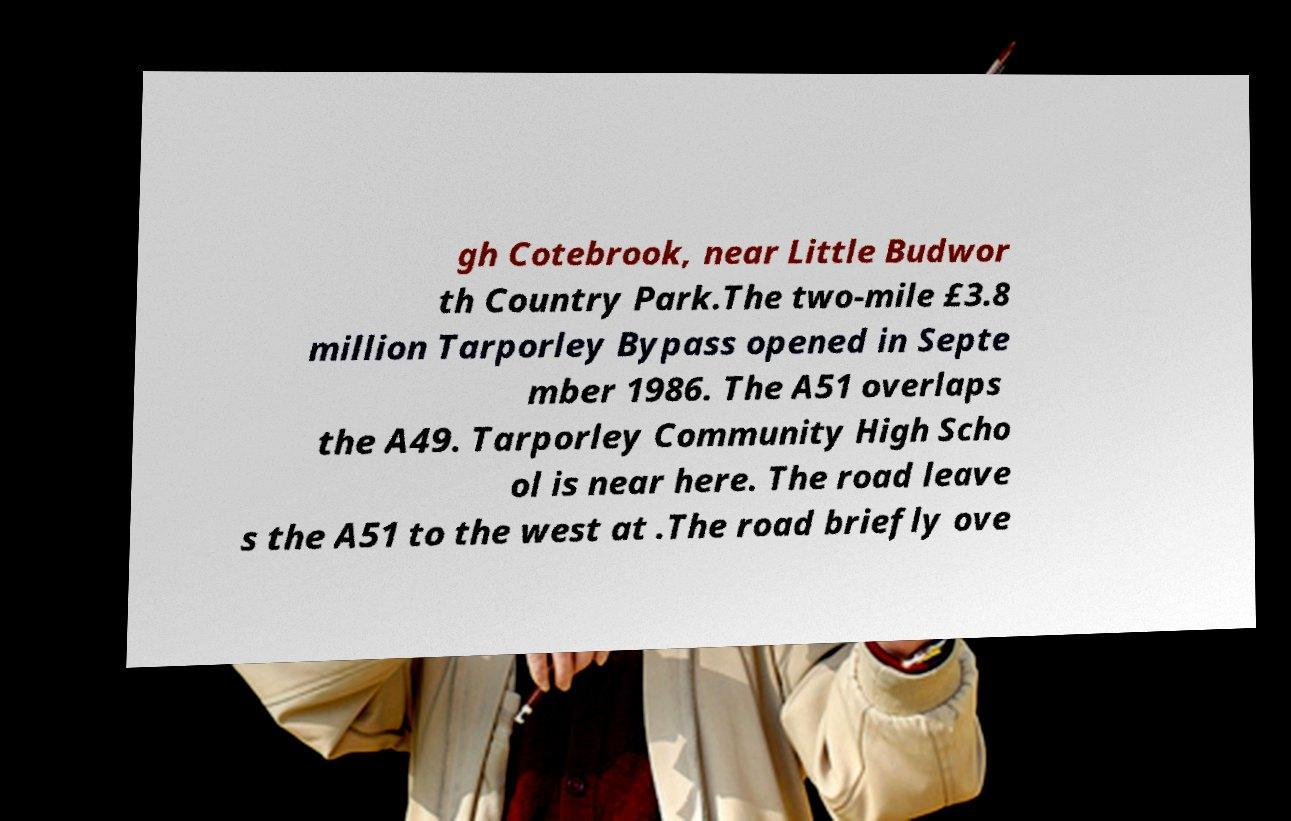For documentation purposes, I need the text within this image transcribed. Could you provide that? gh Cotebrook, near Little Budwor th Country Park.The two-mile £3.8 million Tarporley Bypass opened in Septe mber 1986. The A51 overlaps the A49. Tarporley Community High Scho ol is near here. The road leave s the A51 to the west at .The road briefly ove 